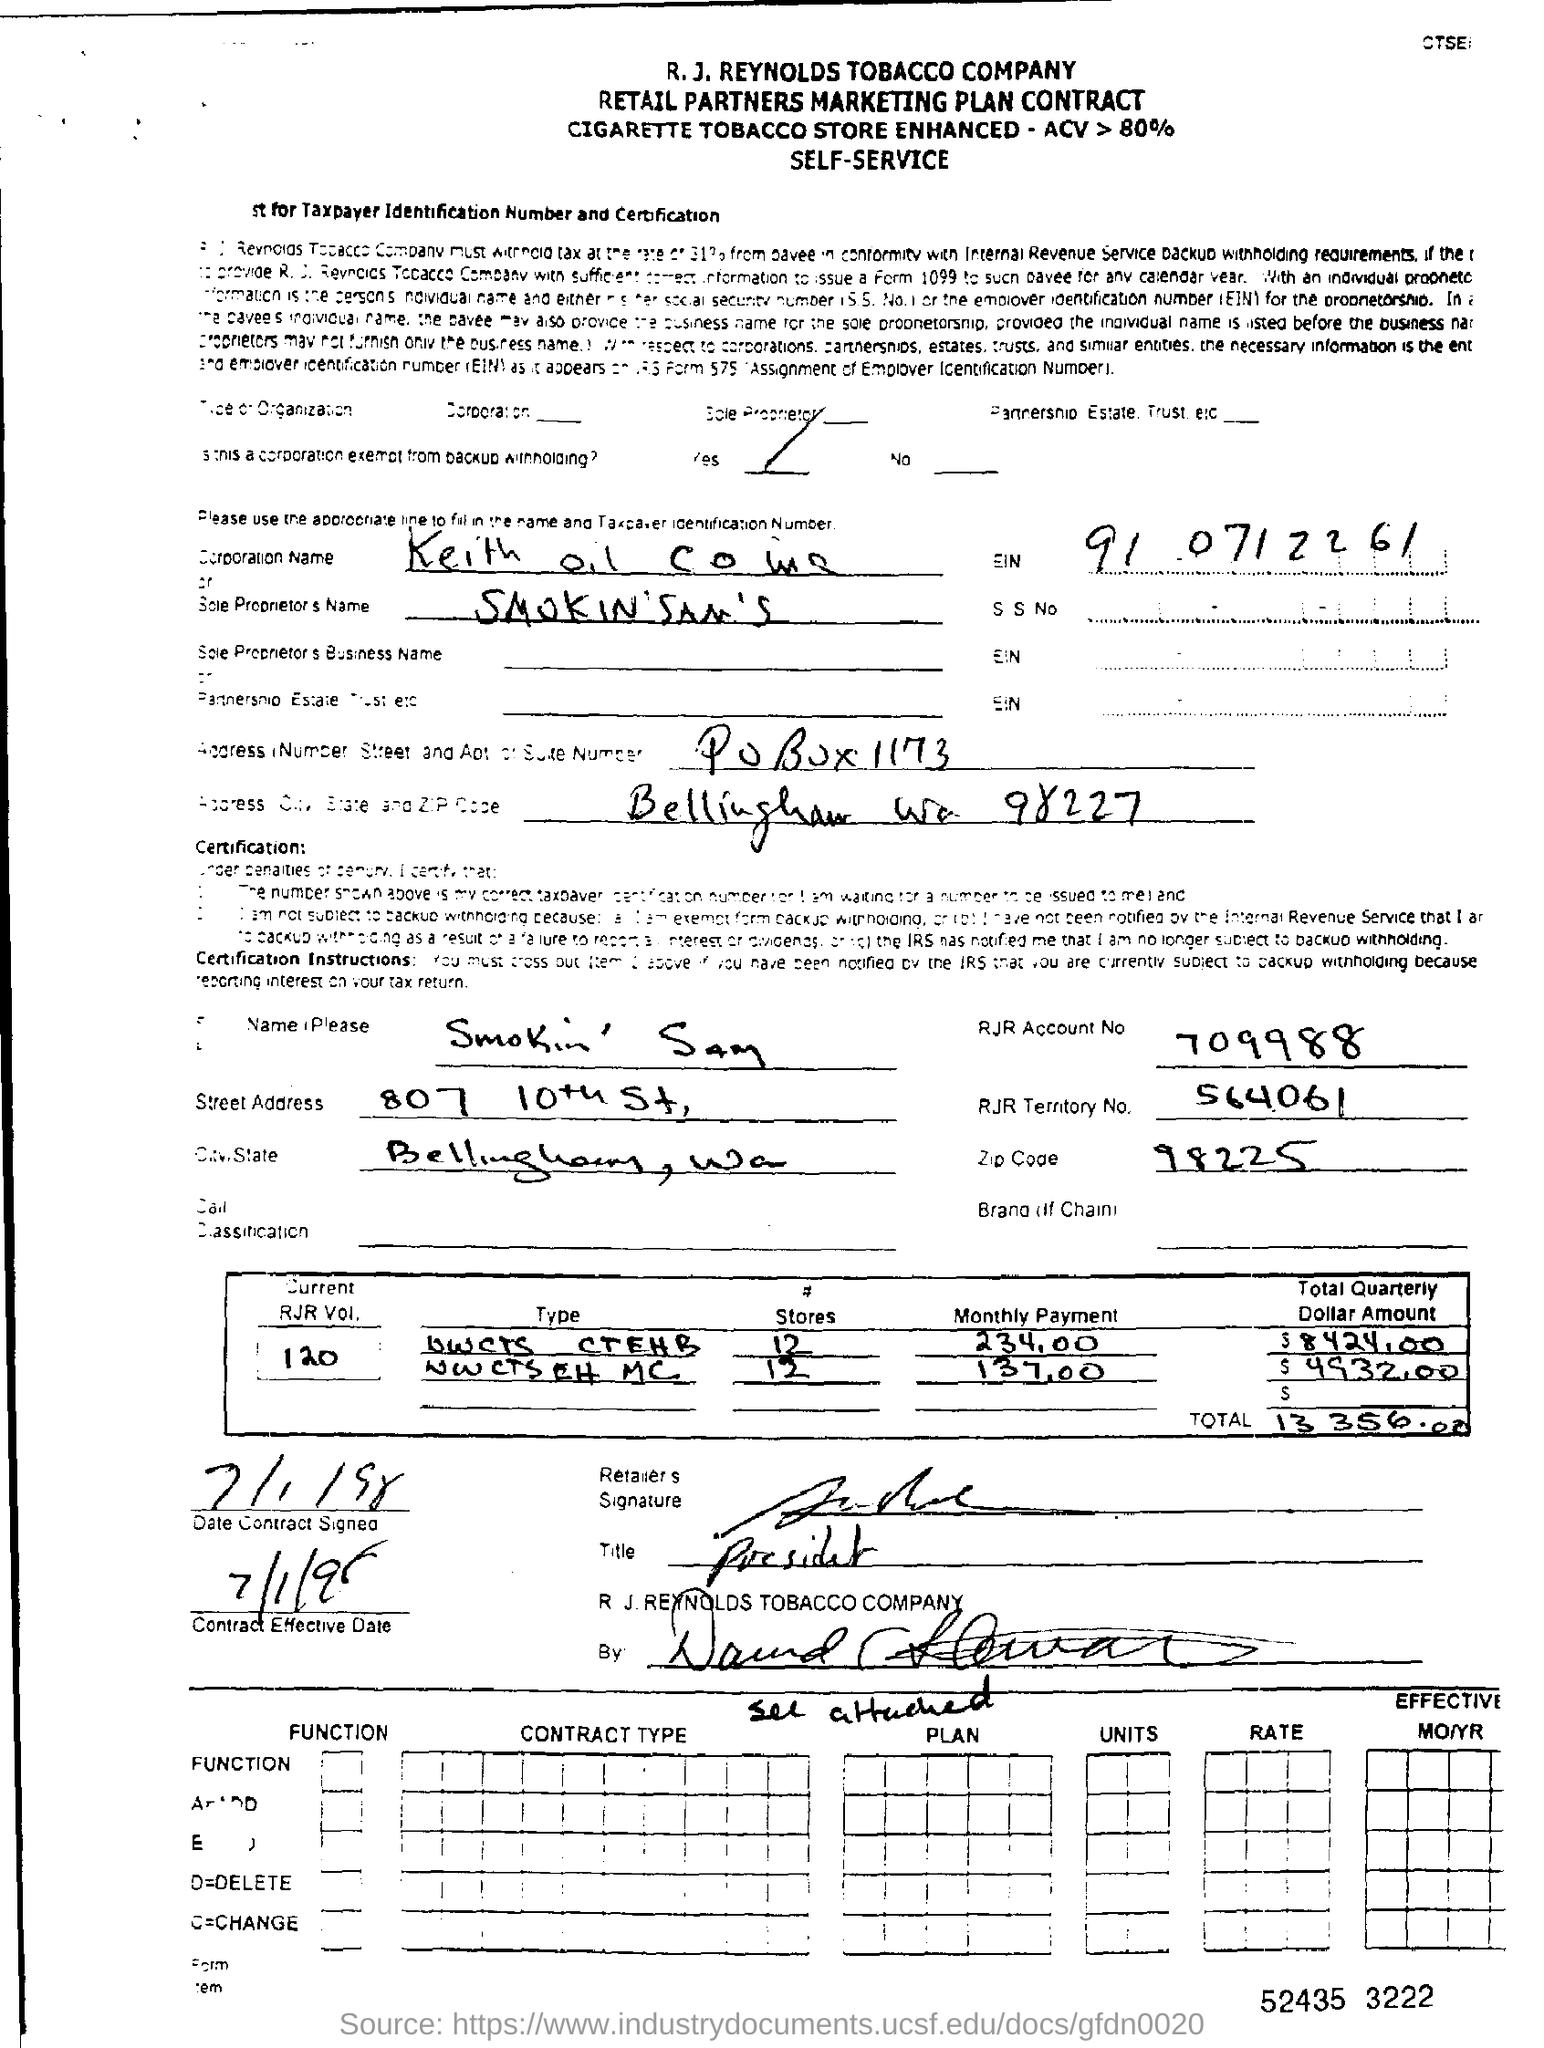What are the financial figures mentioned in the contract? The contract specifies monthly payments for different types of RJR products, with two entries visible indicating monthly amounts of $234.00 and $131.00, which total to a quarterly dollar amount of $1,095.00 and $393.00, respectively. The combined total quarterly dollar amount comes to $13,250.00.  Is there any indication of the contract's effective date or duration? Yes, there is a section at the bottom of the contract that specifies the contract's effective date. It appears to be signed on July 11th, 1988, but we don't have information about the duration from this image alone. Usually, contracts of this nature come with detailed terms and conditions that outline the period of effectiveness. 